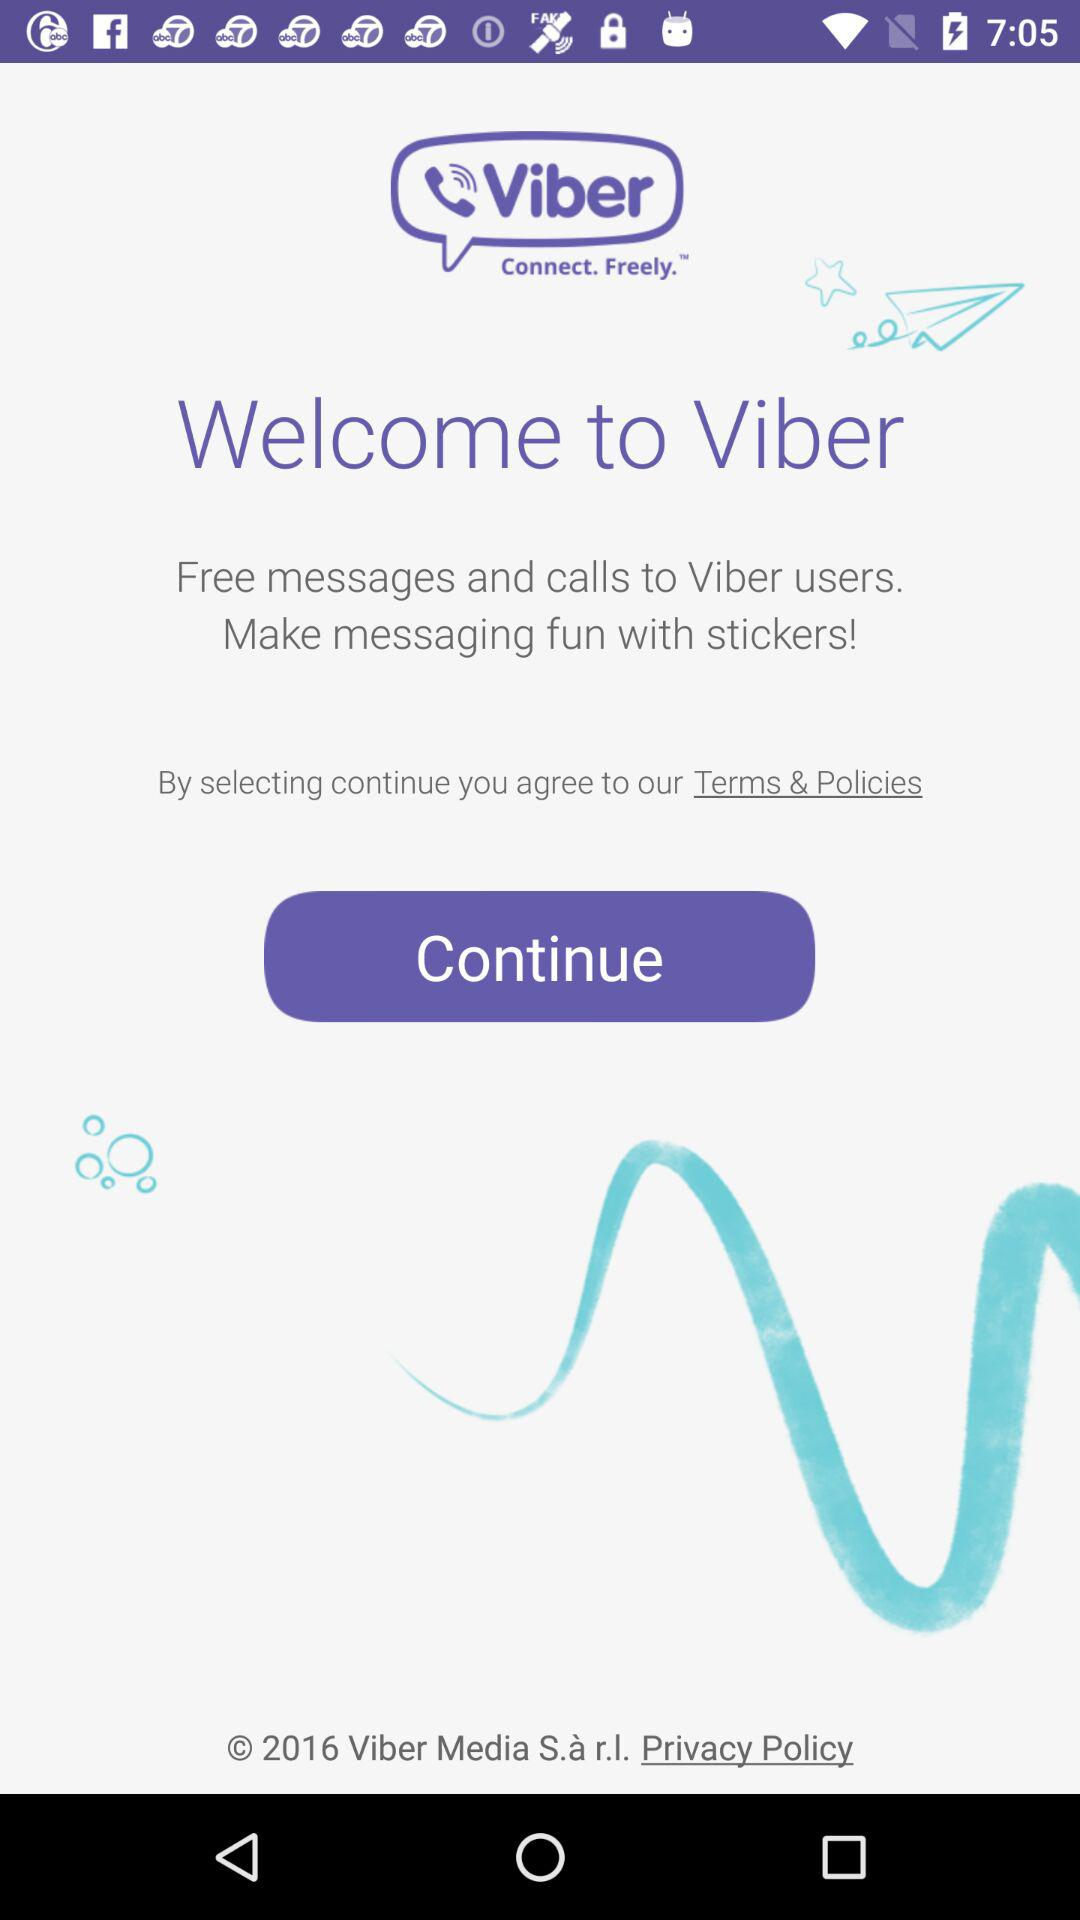What is the application name? The application name is "Viber". 